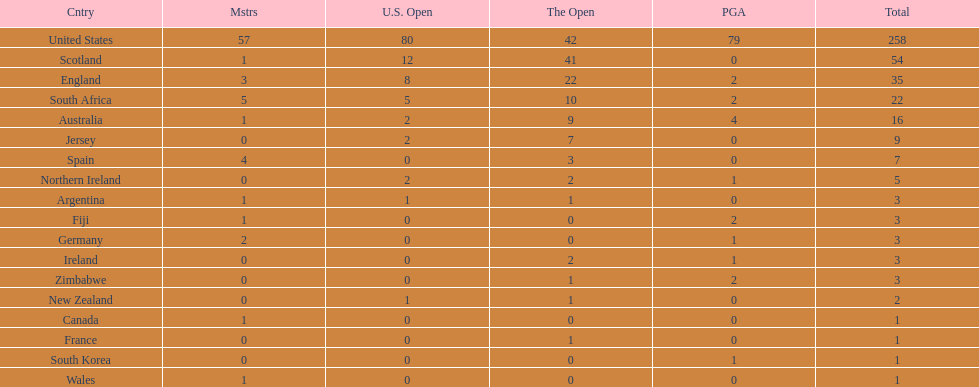What are the number of pga winning golfers that zimbabwe has? 2. Could you help me parse every detail presented in this table? {'header': ['Cntry', 'Mstrs', 'U.S. Open', 'The Open', 'PGA', 'Total'], 'rows': [['United States', '57', '80', '42', '79', '258'], ['Scotland', '1', '12', '41', '0', '54'], ['England', '3', '8', '22', '2', '35'], ['South Africa', '5', '5', '10', '2', '22'], ['Australia', '1', '2', '9', '4', '16'], ['Jersey', '0', '2', '7', '0', '9'], ['Spain', '4', '0', '3', '0', '7'], ['Northern Ireland', '0', '2', '2', '1', '5'], ['Argentina', '1', '1', '1', '0', '3'], ['Fiji', '1', '0', '0', '2', '3'], ['Germany', '2', '0', '0', '1', '3'], ['Ireland', '0', '0', '2', '1', '3'], ['Zimbabwe', '0', '0', '1', '2', '3'], ['New Zealand', '0', '1', '1', '0', '2'], ['Canada', '1', '0', '0', '0', '1'], ['France', '0', '0', '1', '0', '1'], ['South Korea', '0', '0', '0', '1', '1'], ['Wales', '1', '0', '0', '0', '1']]} 